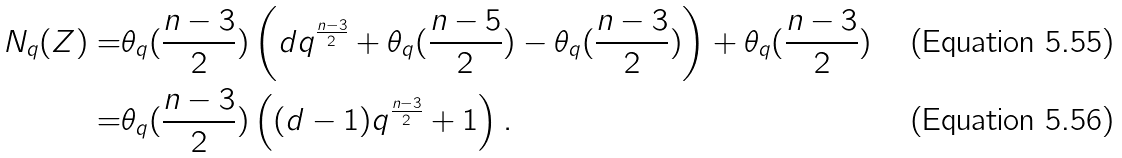<formula> <loc_0><loc_0><loc_500><loc_500>N _ { q } ( Z ) = & \theta _ { q } ( \frac { n - 3 } { 2 } ) \left ( d q ^ { \frac { n - 3 } { 2 } } + \theta _ { q } ( \frac { n - 5 } { 2 } ) - \theta _ { q } ( \frac { n - 3 } { 2 } ) \right ) + \theta _ { q } ( \frac { n - 3 } { 2 } ) \\ = & \theta _ { q } ( \frac { n - 3 } { 2 } ) \left ( ( d - 1 ) q ^ { \frac { n - 3 } { 2 } } + 1 \right ) .</formula> 